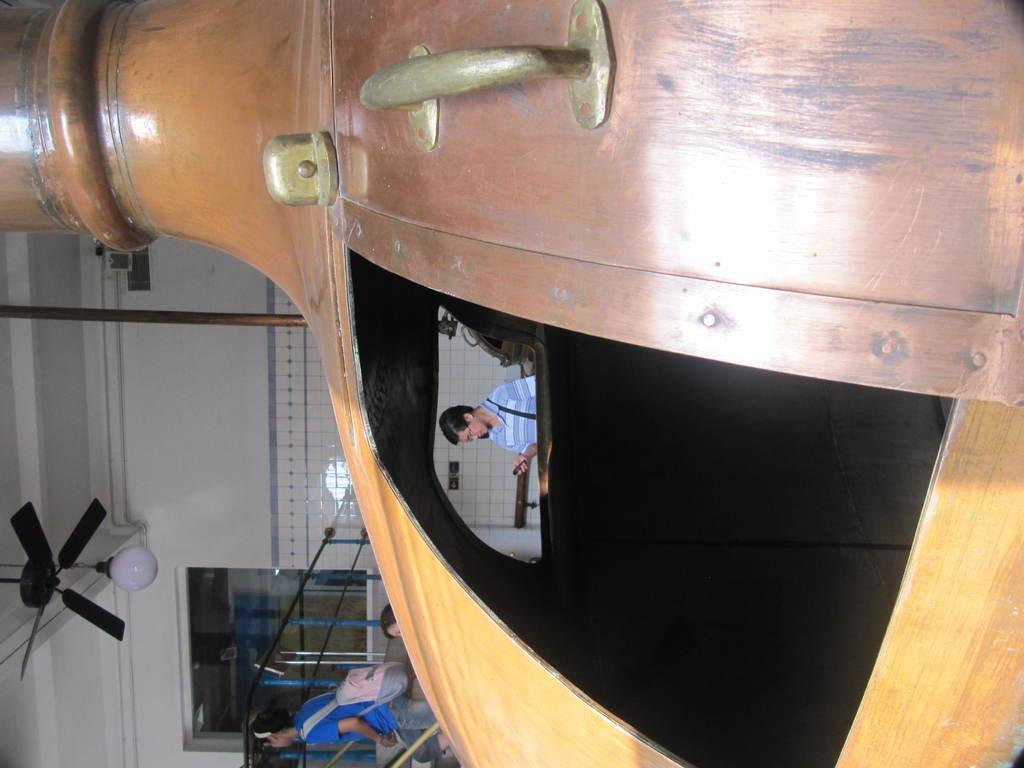Please provide a concise description of this image. In this image we can see a building, at the top we can see a fan and a light, there are some people, also we can see a pole, wall and an object. 